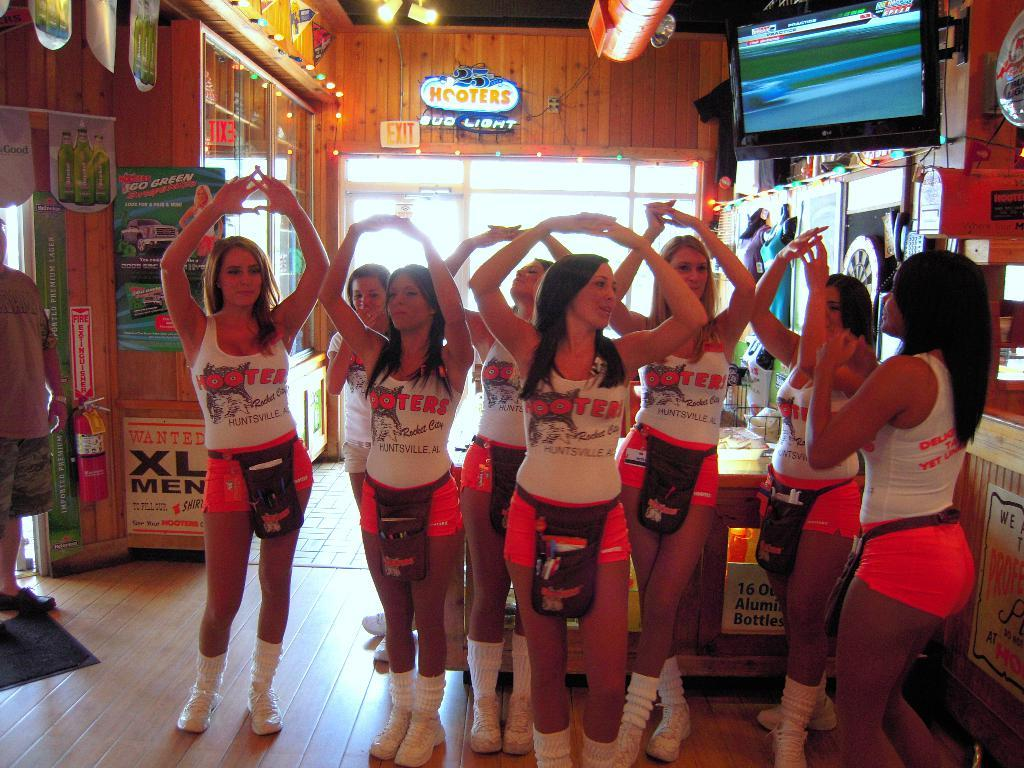<image>
Summarize the visual content of the image. Several women in Hooters shirts hold their arms over their heads. 